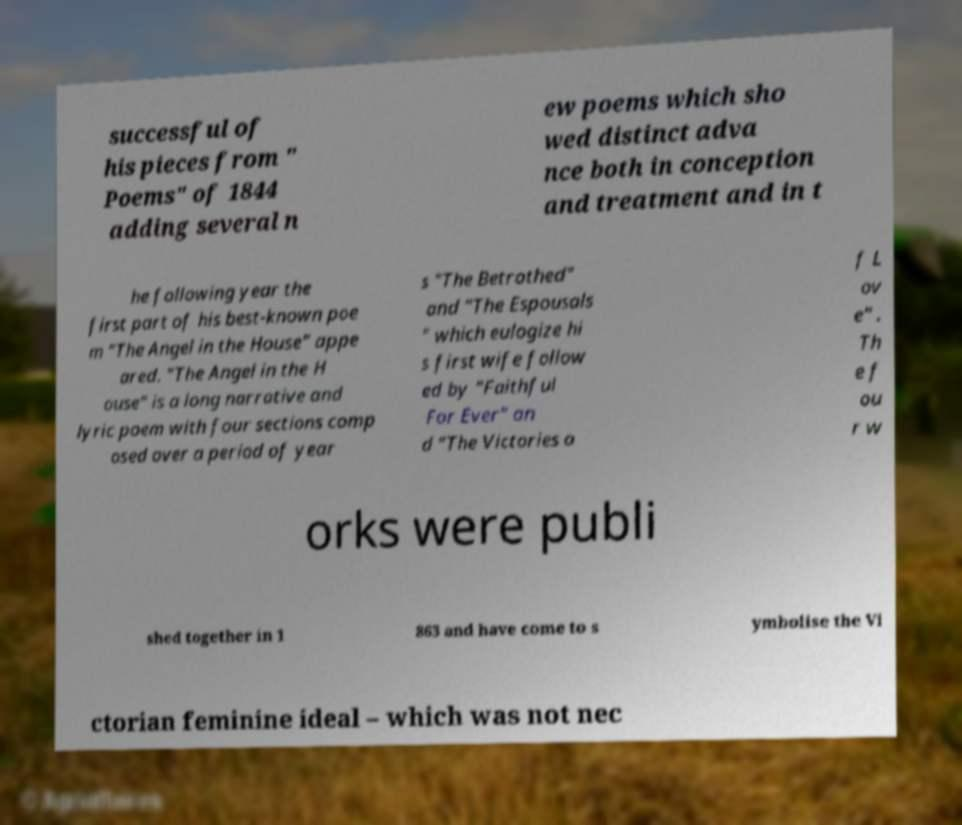Could you assist in decoding the text presented in this image and type it out clearly? successful of his pieces from " Poems" of 1844 adding several n ew poems which sho wed distinct adva nce both in conception and treatment and in t he following year the first part of his best-known poe m "The Angel in the House" appe ared. "The Angel in the H ouse" is a long narrative and lyric poem with four sections comp osed over a period of year s "The Betrothed" and "The Espousals " which eulogize hi s first wife follow ed by "Faithful For Ever" an d "The Victories o f L ov e" . Th e f ou r w orks were publi shed together in 1 863 and have come to s ymbolise the Vi ctorian feminine ideal – which was not nec 